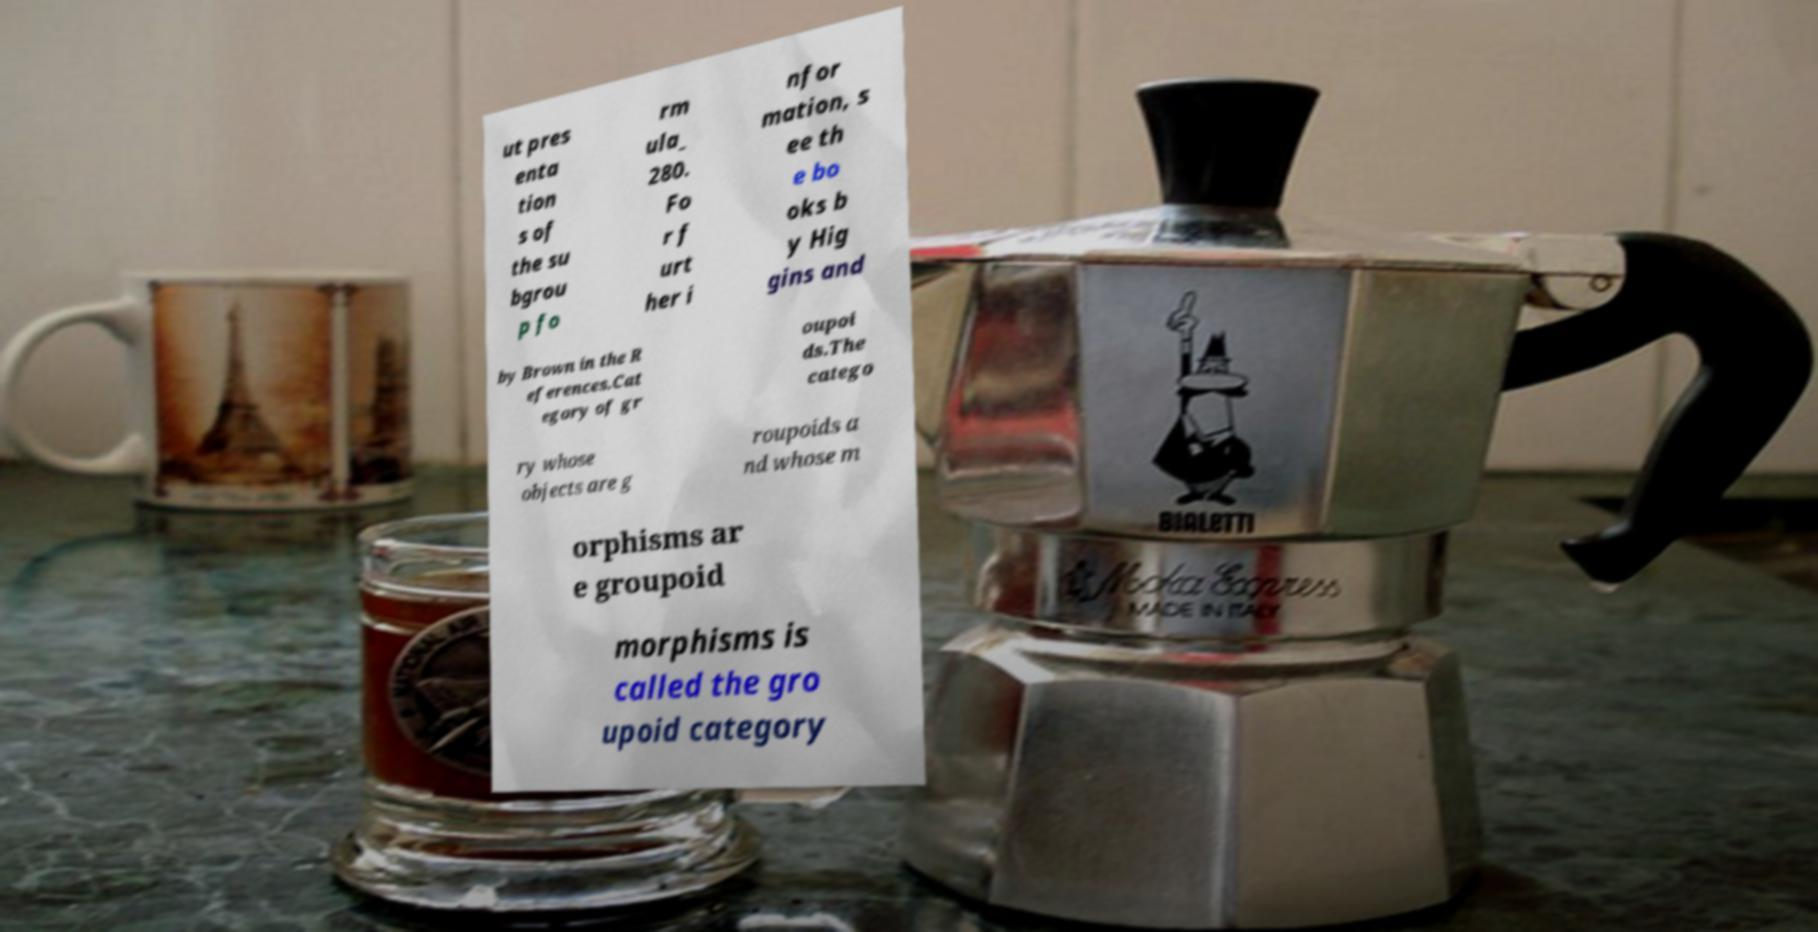Could you extract and type out the text from this image? ut pres enta tion s of the su bgrou p fo rm ula_ 280. Fo r f urt her i nfor mation, s ee th e bo oks b y Hig gins and by Brown in the R eferences.Cat egory of gr oupoi ds.The catego ry whose objects are g roupoids a nd whose m orphisms ar e groupoid morphisms is called the gro upoid category 